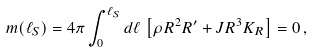Convert formula to latex. <formula><loc_0><loc_0><loc_500><loc_500>m ( \ell _ { S } ) = 4 \pi \int _ { 0 } ^ { \ell _ { S } } d \ell \, \left [ \rho R ^ { 2 } R ^ { \prime } + J R ^ { 3 } K _ { R } \right ] = 0 \, ,</formula> 